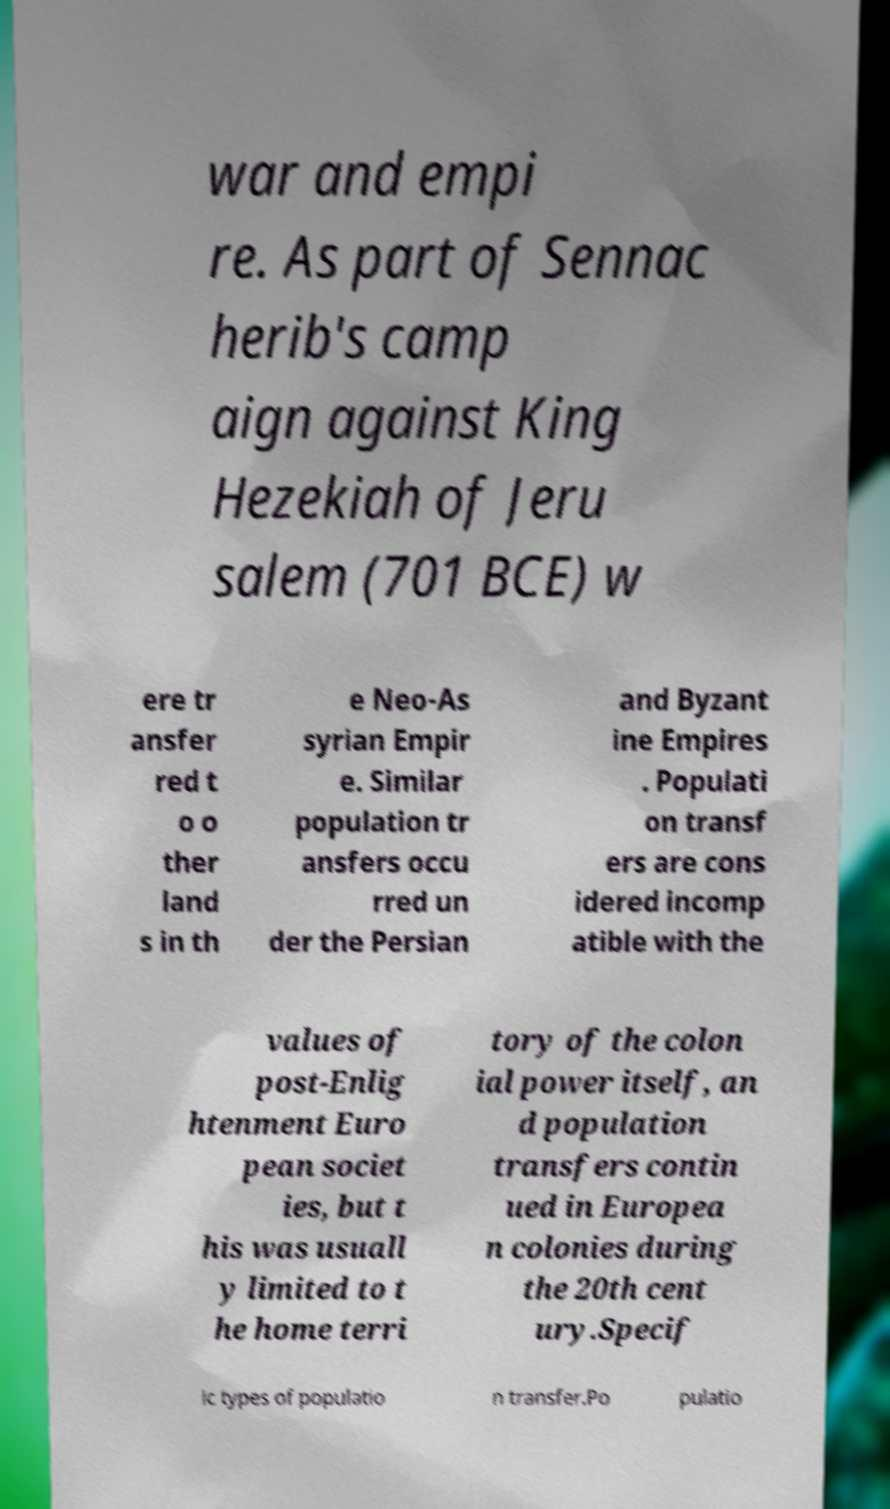Can you accurately transcribe the text from the provided image for me? war and empi re. As part of Sennac herib's camp aign against King Hezekiah of Jeru salem (701 BCE) w ere tr ansfer red t o o ther land s in th e Neo-As syrian Empir e. Similar population tr ansfers occu rred un der the Persian and Byzant ine Empires . Populati on transf ers are cons idered incomp atible with the values of post-Enlig htenment Euro pean societ ies, but t his was usuall y limited to t he home terri tory of the colon ial power itself, an d population transfers contin ued in Europea n colonies during the 20th cent ury.Specif ic types of populatio n transfer.Po pulatio 